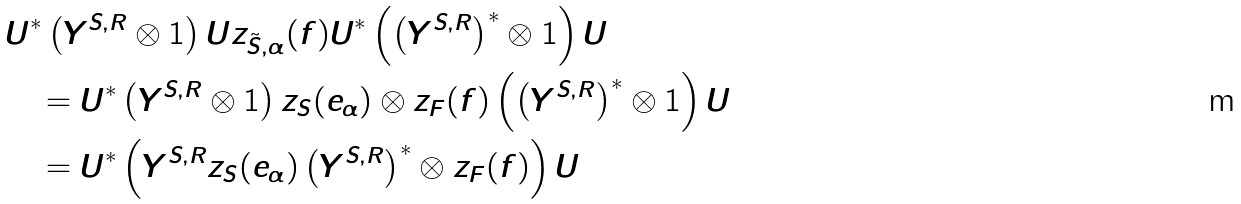<formula> <loc_0><loc_0><loc_500><loc_500>& U ^ { * } \left ( Y ^ { S , R } \otimes 1 \right ) U z _ { \tilde { S } , \alpha } ( f ) U ^ { * } \left ( \left ( Y ^ { S , R } \right ) ^ { * } \otimes 1 \right ) U \\ & \quad = U ^ { * } \left ( Y ^ { S , R } \otimes 1 \right ) z _ { S } ( e _ { \alpha } ) \otimes z _ { F } ( f ) \left ( \left ( Y ^ { S , R } \right ) ^ { * } \otimes 1 \right ) U \\ & \quad = U ^ { * } \left ( Y ^ { S , R } z _ { S } ( e _ { \alpha } ) \left ( Y ^ { S , R } \right ) ^ { * } \otimes z _ { F } ( f ) \right ) U</formula> 